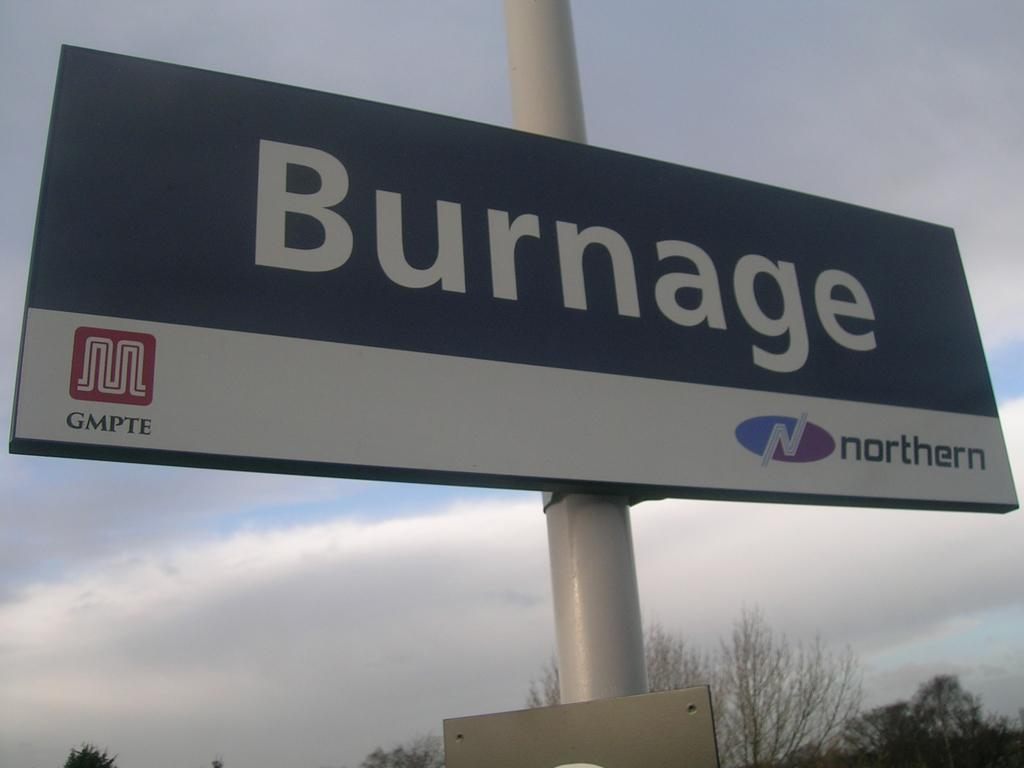Provide a one-sentence caption for the provided image. Big banner on a pole that says Burnage. 